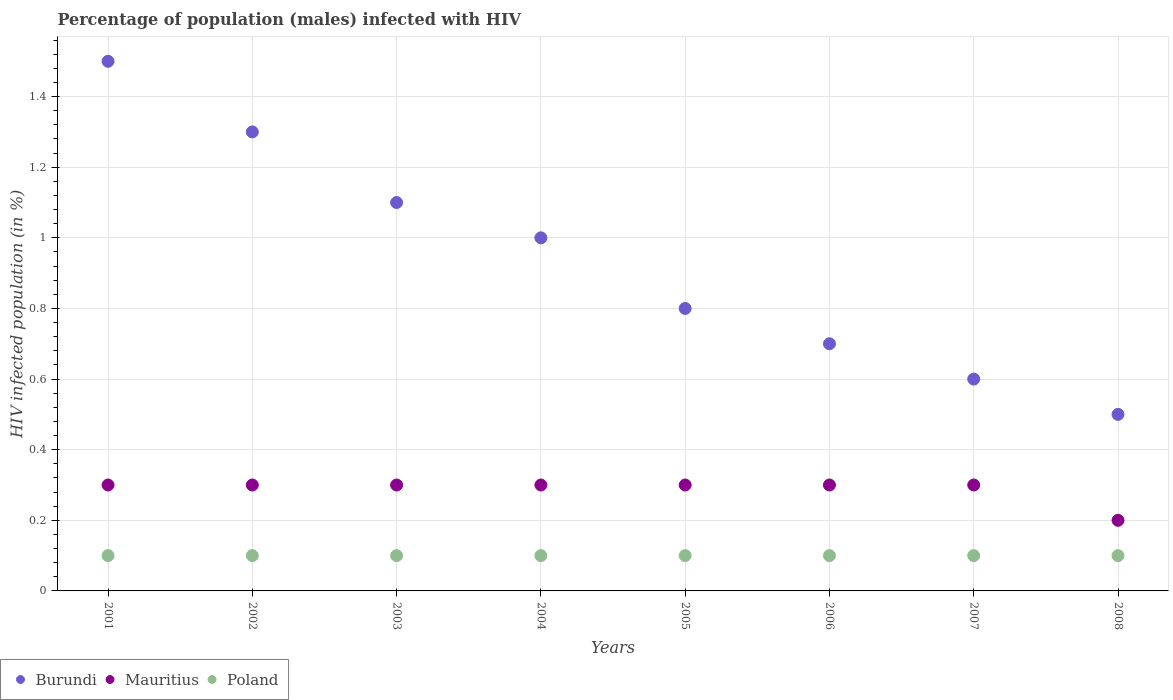Is the number of dotlines equal to the number of legend labels?
Your answer should be compact. Yes. What is the percentage of HIV infected male population in Burundi in 2005?
Offer a terse response. 0.8. In which year was the percentage of HIV infected male population in Burundi maximum?
Your response must be concise. 2001. What is the difference between the percentage of HIV infected male population in Poland in 2005 and that in 2008?
Provide a succinct answer. 0. What is the average percentage of HIV infected male population in Burundi per year?
Ensure brevity in your answer.  0.94. In the year 2005, what is the difference between the percentage of HIV infected male population in Mauritius and percentage of HIV infected male population in Burundi?
Make the answer very short. -0.5. What is the ratio of the percentage of HIV infected male population in Mauritius in 2002 to that in 2008?
Ensure brevity in your answer.  1.5. Is the difference between the percentage of HIV infected male population in Mauritius in 2001 and 2002 greater than the difference between the percentage of HIV infected male population in Burundi in 2001 and 2002?
Your answer should be very brief. No. What is the difference between the highest and the second highest percentage of HIV infected male population in Mauritius?
Provide a succinct answer. 0. What is the difference between the highest and the lowest percentage of HIV infected male population in Burundi?
Give a very brief answer. 1. Is the sum of the percentage of HIV infected male population in Burundi in 2005 and 2008 greater than the maximum percentage of HIV infected male population in Poland across all years?
Your response must be concise. Yes. Is the percentage of HIV infected male population in Burundi strictly less than the percentage of HIV infected male population in Poland over the years?
Offer a very short reply. No. What is the difference between two consecutive major ticks on the Y-axis?
Provide a succinct answer. 0.2. Are the values on the major ticks of Y-axis written in scientific E-notation?
Provide a succinct answer. No. Does the graph contain any zero values?
Your answer should be very brief. No. Does the graph contain grids?
Make the answer very short. Yes. Where does the legend appear in the graph?
Offer a very short reply. Bottom left. How many legend labels are there?
Give a very brief answer. 3. How are the legend labels stacked?
Make the answer very short. Horizontal. What is the title of the graph?
Your answer should be very brief. Percentage of population (males) infected with HIV. Does "Cameroon" appear as one of the legend labels in the graph?
Ensure brevity in your answer.  No. What is the label or title of the Y-axis?
Your answer should be very brief. HIV infected population (in %). What is the HIV infected population (in %) in Poland in 2002?
Your answer should be very brief. 0.1. What is the HIV infected population (in %) in Burundi in 2005?
Provide a succinct answer. 0.8. What is the HIV infected population (in %) in Mauritius in 2005?
Provide a succinct answer. 0.3. What is the HIV infected population (in %) in Poland in 2005?
Give a very brief answer. 0.1. What is the HIV infected population (in %) of Mauritius in 2006?
Make the answer very short. 0.3. What is the HIV infected population (in %) in Poland in 2007?
Make the answer very short. 0.1. What is the HIV infected population (in %) in Burundi in 2008?
Your response must be concise. 0.5. What is the HIV infected population (in %) in Poland in 2008?
Give a very brief answer. 0.1. Across all years, what is the maximum HIV infected population (in %) of Mauritius?
Ensure brevity in your answer.  0.3. Across all years, what is the minimum HIV infected population (in %) in Burundi?
Provide a short and direct response. 0.5. Across all years, what is the minimum HIV infected population (in %) of Poland?
Your answer should be very brief. 0.1. What is the total HIV infected population (in %) in Burundi in the graph?
Provide a succinct answer. 7.5. What is the total HIV infected population (in %) in Mauritius in the graph?
Ensure brevity in your answer.  2.3. What is the total HIV infected population (in %) of Poland in the graph?
Your answer should be compact. 0.8. What is the difference between the HIV infected population (in %) in Mauritius in 2001 and that in 2002?
Give a very brief answer. 0. What is the difference between the HIV infected population (in %) in Mauritius in 2001 and that in 2003?
Keep it short and to the point. 0. What is the difference between the HIV infected population (in %) in Burundi in 2001 and that in 2004?
Keep it short and to the point. 0.5. What is the difference between the HIV infected population (in %) of Burundi in 2001 and that in 2005?
Your answer should be compact. 0.7. What is the difference between the HIV infected population (in %) in Mauritius in 2001 and that in 2005?
Your response must be concise. 0. What is the difference between the HIV infected population (in %) of Poland in 2001 and that in 2005?
Keep it short and to the point. 0. What is the difference between the HIV infected population (in %) in Poland in 2001 and that in 2006?
Your answer should be compact. 0. What is the difference between the HIV infected population (in %) of Burundi in 2001 and that in 2007?
Your answer should be compact. 0.9. What is the difference between the HIV infected population (in %) in Mauritius in 2001 and that in 2007?
Ensure brevity in your answer.  0. What is the difference between the HIV infected population (in %) in Mauritius in 2001 and that in 2008?
Your response must be concise. 0.1. What is the difference between the HIV infected population (in %) of Poland in 2001 and that in 2008?
Provide a short and direct response. 0. What is the difference between the HIV infected population (in %) in Mauritius in 2002 and that in 2003?
Provide a short and direct response. 0. What is the difference between the HIV infected population (in %) of Mauritius in 2002 and that in 2004?
Keep it short and to the point. 0. What is the difference between the HIV infected population (in %) of Mauritius in 2002 and that in 2005?
Give a very brief answer. 0. What is the difference between the HIV infected population (in %) in Burundi in 2002 and that in 2006?
Offer a very short reply. 0.6. What is the difference between the HIV infected population (in %) of Burundi in 2002 and that in 2007?
Offer a terse response. 0.7. What is the difference between the HIV infected population (in %) in Burundi in 2002 and that in 2008?
Keep it short and to the point. 0.8. What is the difference between the HIV infected population (in %) in Burundi in 2003 and that in 2004?
Give a very brief answer. 0.1. What is the difference between the HIV infected population (in %) in Mauritius in 2003 and that in 2004?
Keep it short and to the point. 0. What is the difference between the HIV infected population (in %) in Mauritius in 2003 and that in 2005?
Keep it short and to the point. 0. What is the difference between the HIV infected population (in %) in Burundi in 2003 and that in 2006?
Your answer should be very brief. 0.4. What is the difference between the HIV infected population (in %) in Poland in 2003 and that in 2008?
Offer a very short reply. 0. What is the difference between the HIV infected population (in %) of Mauritius in 2004 and that in 2005?
Your answer should be compact. 0. What is the difference between the HIV infected population (in %) of Burundi in 2004 and that in 2006?
Offer a very short reply. 0.3. What is the difference between the HIV infected population (in %) of Mauritius in 2004 and that in 2007?
Make the answer very short. 0. What is the difference between the HIV infected population (in %) in Poland in 2004 and that in 2007?
Keep it short and to the point. 0. What is the difference between the HIV infected population (in %) of Burundi in 2004 and that in 2008?
Ensure brevity in your answer.  0.5. What is the difference between the HIV infected population (in %) of Mauritius in 2004 and that in 2008?
Give a very brief answer. 0.1. What is the difference between the HIV infected population (in %) of Burundi in 2005 and that in 2006?
Give a very brief answer. 0.1. What is the difference between the HIV infected population (in %) in Mauritius in 2005 and that in 2006?
Offer a very short reply. 0. What is the difference between the HIV infected population (in %) of Poland in 2005 and that in 2006?
Ensure brevity in your answer.  0. What is the difference between the HIV infected population (in %) of Burundi in 2005 and that in 2007?
Offer a terse response. 0.2. What is the difference between the HIV infected population (in %) in Mauritius in 2005 and that in 2007?
Your answer should be compact. 0. What is the difference between the HIV infected population (in %) in Poland in 2005 and that in 2007?
Offer a terse response. 0. What is the difference between the HIV infected population (in %) of Burundi in 2005 and that in 2008?
Offer a very short reply. 0.3. What is the difference between the HIV infected population (in %) of Poland in 2005 and that in 2008?
Your answer should be compact. 0. What is the difference between the HIV infected population (in %) in Burundi in 2006 and that in 2007?
Your response must be concise. 0.1. What is the difference between the HIV infected population (in %) of Poland in 2006 and that in 2007?
Offer a very short reply. 0. What is the difference between the HIV infected population (in %) in Burundi in 2006 and that in 2008?
Keep it short and to the point. 0.2. What is the difference between the HIV infected population (in %) of Mauritius in 2006 and that in 2008?
Give a very brief answer. 0.1. What is the difference between the HIV infected population (in %) in Poland in 2006 and that in 2008?
Give a very brief answer. 0. What is the difference between the HIV infected population (in %) of Poland in 2007 and that in 2008?
Make the answer very short. 0. What is the difference between the HIV infected population (in %) of Burundi in 2001 and the HIV infected population (in %) of Poland in 2002?
Provide a succinct answer. 1.4. What is the difference between the HIV infected population (in %) of Mauritius in 2001 and the HIV infected population (in %) of Poland in 2002?
Your answer should be compact. 0.2. What is the difference between the HIV infected population (in %) in Burundi in 2001 and the HIV infected population (in %) in Poland in 2003?
Provide a succinct answer. 1.4. What is the difference between the HIV infected population (in %) of Mauritius in 2001 and the HIV infected population (in %) of Poland in 2003?
Your answer should be very brief. 0.2. What is the difference between the HIV infected population (in %) of Burundi in 2001 and the HIV infected population (in %) of Mauritius in 2004?
Your response must be concise. 1.2. What is the difference between the HIV infected population (in %) in Burundi in 2001 and the HIV infected population (in %) in Poland in 2004?
Ensure brevity in your answer.  1.4. What is the difference between the HIV infected population (in %) in Mauritius in 2001 and the HIV infected population (in %) in Poland in 2004?
Ensure brevity in your answer.  0.2. What is the difference between the HIV infected population (in %) of Mauritius in 2001 and the HIV infected population (in %) of Poland in 2005?
Offer a terse response. 0.2. What is the difference between the HIV infected population (in %) of Burundi in 2001 and the HIV infected population (in %) of Mauritius in 2006?
Provide a short and direct response. 1.2. What is the difference between the HIV infected population (in %) in Burundi in 2001 and the HIV infected population (in %) in Poland in 2006?
Your answer should be very brief. 1.4. What is the difference between the HIV infected population (in %) of Mauritius in 2001 and the HIV infected population (in %) of Poland in 2006?
Keep it short and to the point. 0.2. What is the difference between the HIV infected population (in %) of Mauritius in 2001 and the HIV infected population (in %) of Poland in 2007?
Your answer should be very brief. 0.2. What is the difference between the HIV infected population (in %) of Mauritius in 2001 and the HIV infected population (in %) of Poland in 2008?
Give a very brief answer. 0.2. What is the difference between the HIV infected population (in %) in Burundi in 2002 and the HIV infected population (in %) in Mauritius in 2003?
Ensure brevity in your answer.  1. What is the difference between the HIV infected population (in %) of Mauritius in 2002 and the HIV infected population (in %) of Poland in 2003?
Offer a terse response. 0.2. What is the difference between the HIV infected population (in %) in Burundi in 2002 and the HIV infected population (in %) in Mauritius in 2004?
Your answer should be compact. 1. What is the difference between the HIV infected population (in %) of Burundi in 2002 and the HIV infected population (in %) of Mauritius in 2005?
Give a very brief answer. 1. What is the difference between the HIV infected population (in %) of Burundi in 2002 and the HIV infected population (in %) of Poland in 2005?
Your response must be concise. 1.2. What is the difference between the HIV infected population (in %) of Mauritius in 2002 and the HIV infected population (in %) of Poland in 2005?
Ensure brevity in your answer.  0.2. What is the difference between the HIV infected population (in %) in Burundi in 2002 and the HIV infected population (in %) in Mauritius in 2007?
Offer a terse response. 1. What is the difference between the HIV infected population (in %) in Mauritius in 2002 and the HIV infected population (in %) in Poland in 2007?
Keep it short and to the point. 0.2. What is the difference between the HIV infected population (in %) in Burundi in 2002 and the HIV infected population (in %) in Mauritius in 2008?
Provide a succinct answer. 1.1. What is the difference between the HIV infected population (in %) in Burundi in 2003 and the HIV infected population (in %) in Poland in 2004?
Give a very brief answer. 1. What is the difference between the HIV infected population (in %) in Mauritius in 2003 and the HIV infected population (in %) in Poland in 2005?
Your answer should be compact. 0.2. What is the difference between the HIV infected population (in %) in Burundi in 2003 and the HIV infected population (in %) in Mauritius in 2006?
Make the answer very short. 0.8. What is the difference between the HIV infected population (in %) of Burundi in 2003 and the HIV infected population (in %) of Poland in 2006?
Provide a succinct answer. 1. What is the difference between the HIV infected population (in %) in Burundi in 2003 and the HIV infected population (in %) in Mauritius in 2007?
Your answer should be compact. 0.8. What is the difference between the HIV infected population (in %) of Burundi in 2003 and the HIV infected population (in %) of Poland in 2007?
Keep it short and to the point. 1. What is the difference between the HIV infected population (in %) in Mauritius in 2003 and the HIV infected population (in %) in Poland in 2007?
Give a very brief answer. 0.2. What is the difference between the HIV infected population (in %) in Burundi in 2003 and the HIV infected population (in %) in Poland in 2008?
Make the answer very short. 1. What is the difference between the HIV infected population (in %) of Mauritius in 2003 and the HIV infected population (in %) of Poland in 2008?
Offer a very short reply. 0.2. What is the difference between the HIV infected population (in %) of Burundi in 2004 and the HIV infected population (in %) of Mauritius in 2005?
Provide a short and direct response. 0.7. What is the difference between the HIV infected population (in %) in Burundi in 2004 and the HIV infected population (in %) in Mauritius in 2006?
Your answer should be compact. 0.7. What is the difference between the HIV infected population (in %) of Burundi in 2004 and the HIV infected population (in %) of Poland in 2006?
Keep it short and to the point. 0.9. What is the difference between the HIV infected population (in %) of Mauritius in 2004 and the HIV infected population (in %) of Poland in 2006?
Your response must be concise. 0.2. What is the difference between the HIV infected population (in %) of Burundi in 2004 and the HIV infected population (in %) of Mauritius in 2007?
Give a very brief answer. 0.7. What is the difference between the HIV infected population (in %) in Mauritius in 2004 and the HIV infected population (in %) in Poland in 2007?
Provide a succinct answer. 0.2. What is the difference between the HIV infected population (in %) in Burundi in 2004 and the HIV infected population (in %) in Mauritius in 2008?
Keep it short and to the point. 0.8. What is the difference between the HIV infected population (in %) in Mauritius in 2005 and the HIV infected population (in %) in Poland in 2006?
Provide a short and direct response. 0.2. What is the difference between the HIV infected population (in %) in Burundi in 2005 and the HIV infected population (in %) in Mauritius in 2007?
Your response must be concise. 0.5. What is the difference between the HIV infected population (in %) of Burundi in 2005 and the HIV infected population (in %) of Poland in 2007?
Offer a terse response. 0.7. What is the difference between the HIV infected population (in %) in Mauritius in 2005 and the HIV infected population (in %) in Poland in 2007?
Provide a short and direct response. 0.2. What is the difference between the HIV infected population (in %) in Burundi in 2005 and the HIV infected population (in %) in Mauritius in 2008?
Your response must be concise. 0.6. What is the difference between the HIV infected population (in %) of Burundi in 2005 and the HIV infected population (in %) of Poland in 2008?
Provide a short and direct response. 0.7. What is the difference between the HIV infected population (in %) of Mauritius in 2005 and the HIV infected population (in %) of Poland in 2008?
Your answer should be compact. 0.2. What is the difference between the HIV infected population (in %) of Burundi in 2006 and the HIV infected population (in %) of Mauritius in 2007?
Provide a succinct answer. 0.4. What is the difference between the HIV infected population (in %) of Burundi in 2006 and the HIV infected population (in %) of Mauritius in 2008?
Your answer should be very brief. 0.5. What is the difference between the HIV infected population (in %) in Burundi in 2007 and the HIV infected population (in %) in Poland in 2008?
Ensure brevity in your answer.  0.5. What is the average HIV infected population (in %) in Burundi per year?
Make the answer very short. 0.94. What is the average HIV infected population (in %) of Mauritius per year?
Offer a very short reply. 0.29. In the year 2001, what is the difference between the HIV infected population (in %) of Burundi and HIV infected population (in %) of Poland?
Keep it short and to the point. 1.4. In the year 2001, what is the difference between the HIV infected population (in %) of Mauritius and HIV infected population (in %) of Poland?
Your answer should be very brief. 0.2. In the year 2002, what is the difference between the HIV infected population (in %) in Burundi and HIV infected population (in %) in Poland?
Provide a succinct answer. 1.2. In the year 2002, what is the difference between the HIV infected population (in %) of Mauritius and HIV infected population (in %) of Poland?
Offer a terse response. 0.2. In the year 2003, what is the difference between the HIV infected population (in %) of Burundi and HIV infected population (in %) of Poland?
Offer a very short reply. 1. In the year 2003, what is the difference between the HIV infected population (in %) in Mauritius and HIV infected population (in %) in Poland?
Provide a succinct answer. 0.2. In the year 2006, what is the difference between the HIV infected population (in %) in Burundi and HIV infected population (in %) in Mauritius?
Offer a very short reply. 0.4. In the year 2006, what is the difference between the HIV infected population (in %) of Burundi and HIV infected population (in %) of Poland?
Provide a succinct answer. 0.6. In the year 2007, what is the difference between the HIV infected population (in %) in Burundi and HIV infected population (in %) in Poland?
Your response must be concise. 0.5. In the year 2008, what is the difference between the HIV infected population (in %) of Burundi and HIV infected population (in %) of Mauritius?
Provide a short and direct response. 0.3. In the year 2008, what is the difference between the HIV infected population (in %) of Burundi and HIV infected population (in %) of Poland?
Your answer should be compact. 0.4. What is the ratio of the HIV infected population (in %) in Burundi in 2001 to that in 2002?
Provide a succinct answer. 1.15. What is the ratio of the HIV infected population (in %) in Mauritius in 2001 to that in 2002?
Make the answer very short. 1. What is the ratio of the HIV infected population (in %) in Poland in 2001 to that in 2002?
Offer a terse response. 1. What is the ratio of the HIV infected population (in %) of Burundi in 2001 to that in 2003?
Keep it short and to the point. 1.36. What is the ratio of the HIV infected population (in %) in Mauritius in 2001 to that in 2003?
Your answer should be very brief. 1. What is the ratio of the HIV infected population (in %) in Poland in 2001 to that in 2003?
Provide a succinct answer. 1. What is the ratio of the HIV infected population (in %) in Burundi in 2001 to that in 2004?
Your response must be concise. 1.5. What is the ratio of the HIV infected population (in %) of Poland in 2001 to that in 2004?
Your answer should be very brief. 1. What is the ratio of the HIV infected population (in %) in Burundi in 2001 to that in 2005?
Your answer should be compact. 1.88. What is the ratio of the HIV infected population (in %) in Mauritius in 2001 to that in 2005?
Your answer should be very brief. 1. What is the ratio of the HIV infected population (in %) in Poland in 2001 to that in 2005?
Your answer should be very brief. 1. What is the ratio of the HIV infected population (in %) of Burundi in 2001 to that in 2006?
Offer a terse response. 2.14. What is the ratio of the HIV infected population (in %) of Burundi in 2001 to that in 2007?
Your answer should be very brief. 2.5. What is the ratio of the HIV infected population (in %) of Poland in 2001 to that in 2007?
Your answer should be compact. 1. What is the ratio of the HIV infected population (in %) in Burundi in 2001 to that in 2008?
Offer a very short reply. 3. What is the ratio of the HIV infected population (in %) of Mauritius in 2001 to that in 2008?
Your response must be concise. 1.5. What is the ratio of the HIV infected population (in %) of Poland in 2001 to that in 2008?
Ensure brevity in your answer.  1. What is the ratio of the HIV infected population (in %) in Burundi in 2002 to that in 2003?
Your answer should be compact. 1.18. What is the ratio of the HIV infected population (in %) of Burundi in 2002 to that in 2004?
Ensure brevity in your answer.  1.3. What is the ratio of the HIV infected population (in %) in Mauritius in 2002 to that in 2004?
Offer a terse response. 1. What is the ratio of the HIV infected population (in %) in Poland in 2002 to that in 2004?
Your response must be concise. 1. What is the ratio of the HIV infected population (in %) of Burundi in 2002 to that in 2005?
Offer a terse response. 1.62. What is the ratio of the HIV infected population (in %) in Poland in 2002 to that in 2005?
Your answer should be compact. 1. What is the ratio of the HIV infected population (in %) of Burundi in 2002 to that in 2006?
Make the answer very short. 1.86. What is the ratio of the HIV infected population (in %) in Poland in 2002 to that in 2006?
Offer a terse response. 1. What is the ratio of the HIV infected population (in %) in Burundi in 2002 to that in 2007?
Provide a succinct answer. 2.17. What is the ratio of the HIV infected population (in %) in Poland in 2002 to that in 2007?
Your response must be concise. 1. What is the ratio of the HIV infected population (in %) in Mauritius in 2003 to that in 2004?
Keep it short and to the point. 1. What is the ratio of the HIV infected population (in %) of Poland in 2003 to that in 2004?
Your response must be concise. 1. What is the ratio of the HIV infected population (in %) in Burundi in 2003 to that in 2005?
Give a very brief answer. 1.38. What is the ratio of the HIV infected population (in %) in Mauritius in 2003 to that in 2005?
Offer a terse response. 1. What is the ratio of the HIV infected population (in %) of Burundi in 2003 to that in 2006?
Give a very brief answer. 1.57. What is the ratio of the HIV infected population (in %) in Mauritius in 2003 to that in 2006?
Your answer should be compact. 1. What is the ratio of the HIV infected population (in %) in Burundi in 2003 to that in 2007?
Your answer should be very brief. 1.83. What is the ratio of the HIV infected population (in %) of Poland in 2003 to that in 2007?
Offer a very short reply. 1. What is the ratio of the HIV infected population (in %) in Poland in 2003 to that in 2008?
Your answer should be very brief. 1. What is the ratio of the HIV infected population (in %) of Mauritius in 2004 to that in 2005?
Provide a short and direct response. 1. What is the ratio of the HIV infected population (in %) in Burundi in 2004 to that in 2006?
Give a very brief answer. 1.43. What is the ratio of the HIV infected population (in %) in Poland in 2004 to that in 2006?
Provide a succinct answer. 1. What is the ratio of the HIV infected population (in %) in Poland in 2004 to that in 2008?
Your answer should be very brief. 1. What is the ratio of the HIV infected population (in %) in Burundi in 2005 to that in 2006?
Make the answer very short. 1.14. What is the ratio of the HIV infected population (in %) of Poland in 2005 to that in 2007?
Your answer should be very brief. 1. What is the ratio of the HIV infected population (in %) in Mauritius in 2005 to that in 2008?
Make the answer very short. 1.5. What is the ratio of the HIV infected population (in %) in Mauritius in 2006 to that in 2007?
Your answer should be very brief. 1. What is the ratio of the HIV infected population (in %) of Poland in 2006 to that in 2007?
Make the answer very short. 1. What is the ratio of the HIV infected population (in %) of Mauritius in 2006 to that in 2008?
Offer a very short reply. 1.5. What is the ratio of the HIV infected population (in %) of Burundi in 2007 to that in 2008?
Your answer should be compact. 1.2. What is the ratio of the HIV infected population (in %) in Poland in 2007 to that in 2008?
Offer a terse response. 1. What is the difference between the highest and the second highest HIV infected population (in %) in Mauritius?
Make the answer very short. 0. What is the difference between the highest and the lowest HIV infected population (in %) in Burundi?
Your answer should be very brief. 1. What is the difference between the highest and the lowest HIV infected population (in %) in Poland?
Provide a short and direct response. 0. 